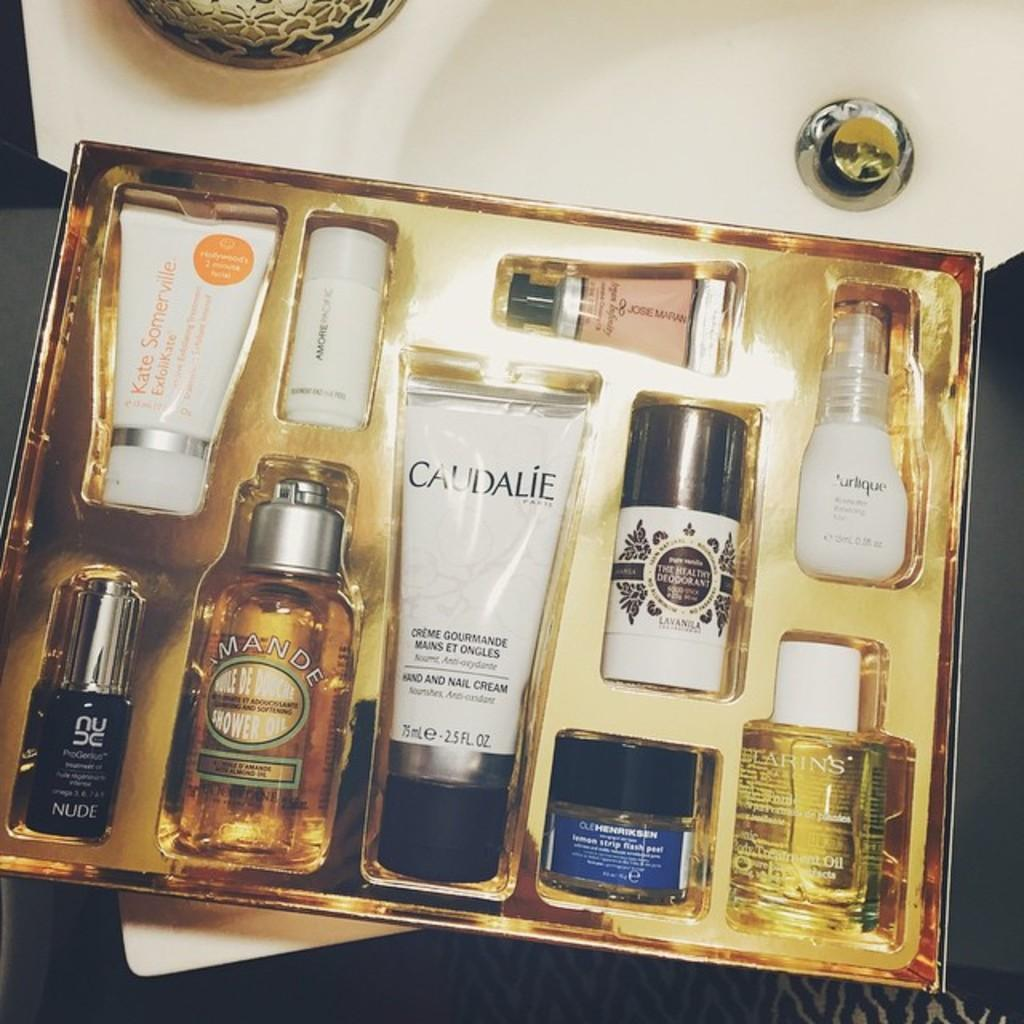<image>
Write a terse but informative summary of the picture. Box of perfume including a bottle that says Caudalie. 